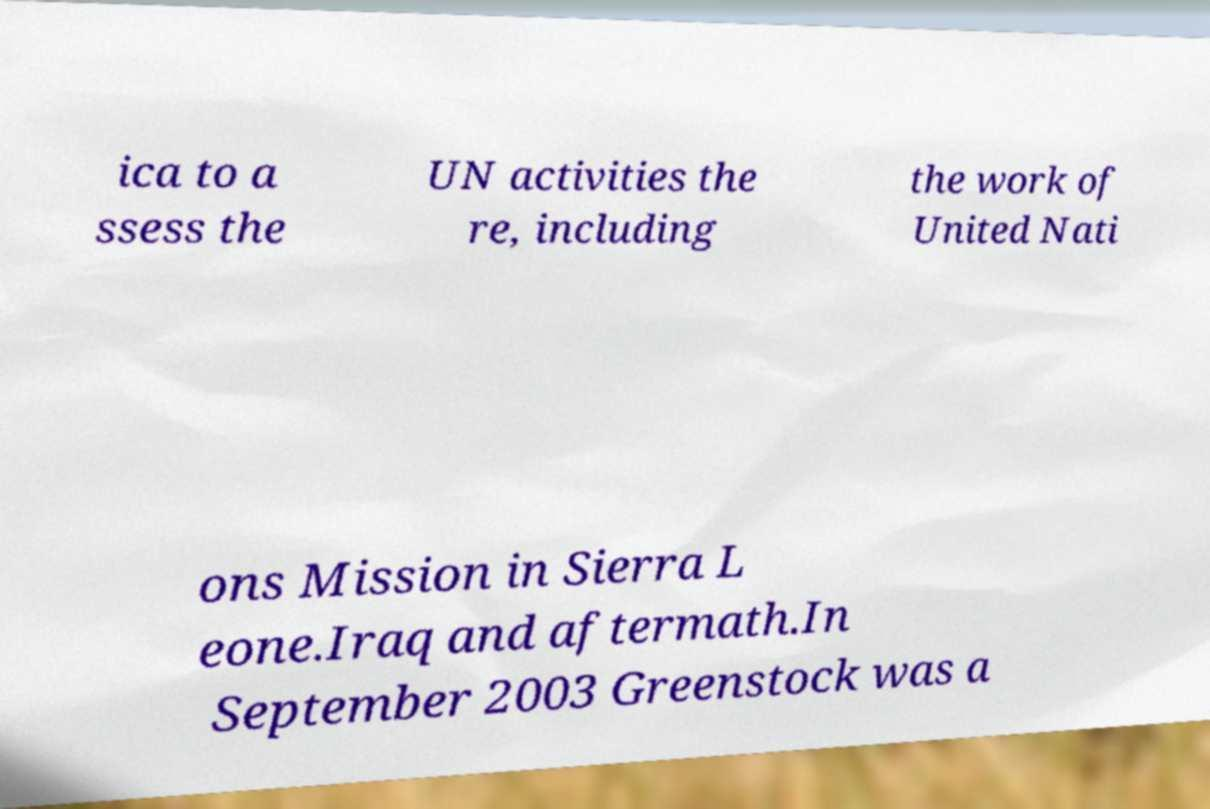Could you assist in decoding the text presented in this image and type it out clearly? ica to a ssess the UN activities the re, including the work of United Nati ons Mission in Sierra L eone.Iraq and aftermath.In September 2003 Greenstock was a 